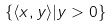Convert formula to latex. <formula><loc_0><loc_0><loc_500><loc_500>\{ \langle x , y \rangle | y > 0 \}</formula> 